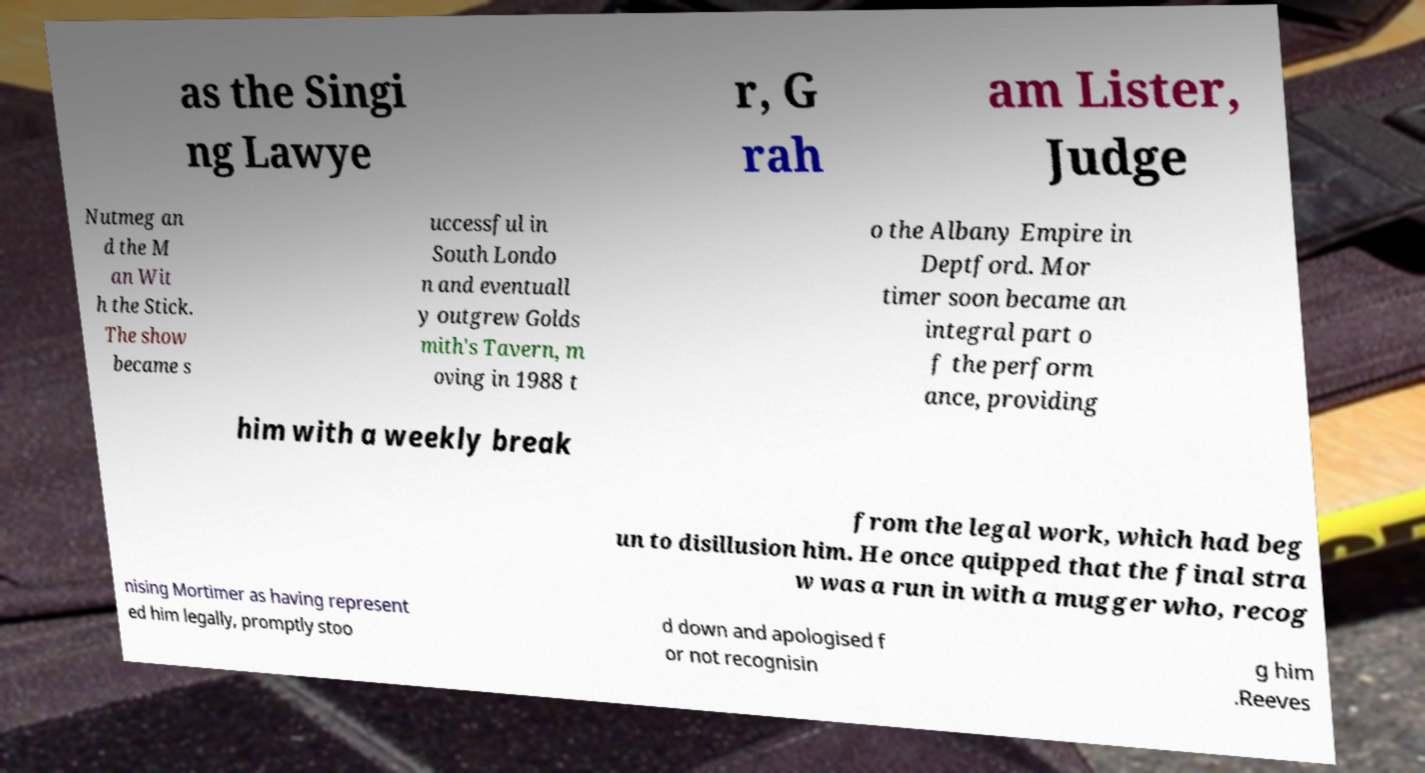I need the written content from this picture converted into text. Can you do that? as the Singi ng Lawye r, G rah am Lister, Judge Nutmeg an d the M an Wit h the Stick. The show became s uccessful in South Londo n and eventuall y outgrew Golds mith's Tavern, m oving in 1988 t o the Albany Empire in Deptford. Mor timer soon became an integral part o f the perform ance, providing him with a weekly break from the legal work, which had beg un to disillusion him. He once quipped that the final stra w was a run in with a mugger who, recog nising Mortimer as having represent ed him legally, promptly stoo d down and apologised f or not recognisin g him .Reeves 